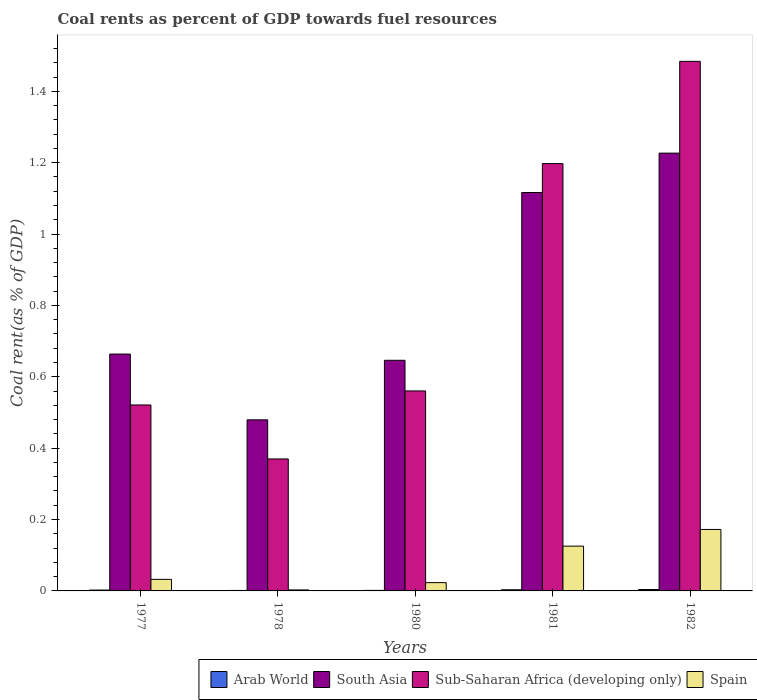How many groups of bars are there?
Your response must be concise. 5. Are the number of bars per tick equal to the number of legend labels?
Provide a short and direct response. Yes. Are the number of bars on each tick of the X-axis equal?
Offer a very short reply. Yes. How many bars are there on the 5th tick from the right?
Provide a succinct answer. 4. In how many cases, is the number of bars for a given year not equal to the number of legend labels?
Offer a terse response. 0. What is the coal rent in South Asia in 1977?
Provide a succinct answer. 0.66. Across all years, what is the maximum coal rent in Sub-Saharan Africa (developing only)?
Provide a short and direct response. 1.48. Across all years, what is the minimum coal rent in Arab World?
Provide a succinct answer. 0. In which year was the coal rent in Spain maximum?
Provide a short and direct response. 1982. In which year was the coal rent in Arab World minimum?
Ensure brevity in your answer.  1978. What is the total coal rent in South Asia in the graph?
Your response must be concise. 4.13. What is the difference between the coal rent in Arab World in 1978 and that in 1981?
Your response must be concise. -0. What is the difference between the coal rent in Arab World in 1981 and the coal rent in South Asia in 1980?
Offer a terse response. -0.64. What is the average coal rent in Arab World per year?
Provide a short and direct response. 0. In the year 1981, what is the difference between the coal rent in Arab World and coal rent in Spain?
Your answer should be very brief. -0.12. In how many years, is the coal rent in Spain greater than 1.08 %?
Ensure brevity in your answer.  0. What is the ratio of the coal rent in Spain in 1980 to that in 1982?
Make the answer very short. 0.13. Is the coal rent in Arab World in 1980 less than that in 1982?
Your response must be concise. Yes. Is the difference between the coal rent in Arab World in 1980 and 1981 greater than the difference between the coal rent in Spain in 1980 and 1981?
Ensure brevity in your answer.  Yes. What is the difference between the highest and the second highest coal rent in Sub-Saharan Africa (developing only)?
Make the answer very short. 0.29. What is the difference between the highest and the lowest coal rent in Arab World?
Offer a terse response. 0. Is it the case that in every year, the sum of the coal rent in Spain and coal rent in Arab World is greater than the sum of coal rent in South Asia and coal rent in Sub-Saharan Africa (developing only)?
Give a very brief answer. No. What does the 1st bar from the left in 1977 represents?
Ensure brevity in your answer.  Arab World. What does the 4th bar from the right in 1978 represents?
Your answer should be very brief. Arab World. How many bars are there?
Offer a terse response. 20. Are all the bars in the graph horizontal?
Provide a succinct answer. No. What is the difference between two consecutive major ticks on the Y-axis?
Your answer should be very brief. 0.2. Does the graph contain any zero values?
Your answer should be compact. No. Does the graph contain grids?
Give a very brief answer. No. How many legend labels are there?
Your answer should be compact. 4. How are the legend labels stacked?
Keep it short and to the point. Horizontal. What is the title of the graph?
Your answer should be very brief. Coal rents as percent of GDP towards fuel resources. What is the label or title of the X-axis?
Give a very brief answer. Years. What is the label or title of the Y-axis?
Offer a very short reply. Coal rent(as % of GDP). What is the Coal rent(as % of GDP) in Arab World in 1977?
Offer a terse response. 0. What is the Coal rent(as % of GDP) of South Asia in 1977?
Make the answer very short. 0.66. What is the Coal rent(as % of GDP) of Sub-Saharan Africa (developing only) in 1977?
Offer a terse response. 0.52. What is the Coal rent(as % of GDP) in Spain in 1977?
Give a very brief answer. 0.03. What is the Coal rent(as % of GDP) of Arab World in 1978?
Make the answer very short. 0. What is the Coal rent(as % of GDP) in South Asia in 1978?
Your response must be concise. 0.48. What is the Coal rent(as % of GDP) in Sub-Saharan Africa (developing only) in 1978?
Keep it short and to the point. 0.37. What is the Coal rent(as % of GDP) in Spain in 1978?
Ensure brevity in your answer.  0. What is the Coal rent(as % of GDP) of Arab World in 1980?
Your answer should be very brief. 0. What is the Coal rent(as % of GDP) of South Asia in 1980?
Provide a succinct answer. 0.65. What is the Coal rent(as % of GDP) of Sub-Saharan Africa (developing only) in 1980?
Your answer should be very brief. 0.56. What is the Coal rent(as % of GDP) in Spain in 1980?
Your answer should be very brief. 0.02. What is the Coal rent(as % of GDP) of Arab World in 1981?
Offer a very short reply. 0. What is the Coal rent(as % of GDP) in South Asia in 1981?
Ensure brevity in your answer.  1.12. What is the Coal rent(as % of GDP) in Sub-Saharan Africa (developing only) in 1981?
Your response must be concise. 1.2. What is the Coal rent(as % of GDP) of Spain in 1981?
Your response must be concise. 0.13. What is the Coal rent(as % of GDP) in Arab World in 1982?
Offer a very short reply. 0. What is the Coal rent(as % of GDP) of South Asia in 1982?
Your answer should be very brief. 1.23. What is the Coal rent(as % of GDP) of Sub-Saharan Africa (developing only) in 1982?
Ensure brevity in your answer.  1.48. What is the Coal rent(as % of GDP) in Spain in 1982?
Offer a terse response. 0.17. Across all years, what is the maximum Coal rent(as % of GDP) of Arab World?
Your answer should be compact. 0. Across all years, what is the maximum Coal rent(as % of GDP) of South Asia?
Your answer should be very brief. 1.23. Across all years, what is the maximum Coal rent(as % of GDP) in Sub-Saharan Africa (developing only)?
Make the answer very short. 1.48. Across all years, what is the maximum Coal rent(as % of GDP) of Spain?
Make the answer very short. 0.17. Across all years, what is the minimum Coal rent(as % of GDP) of Arab World?
Give a very brief answer. 0. Across all years, what is the minimum Coal rent(as % of GDP) in South Asia?
Provide a succinct answer. 0.48. Across all years, what is the minimum Coal rent(as % of GDP) of Sub-Saharan Africa (developing only)?
Provide a short and direct response. 0.37. Across all years, what is the minimum Coal rent(as % of GDP) in Spain?
Provide a short and direct response. 0. What is the total Coal rent(as % of GDP) in Arab World in the graph?
Offer a terse response. 0.01. What is the total Coal rent(as % of GDP) in South Asia in the graph?
Give a very brief answer. 4.13. What is the total Coal rent(as % of GDP) in Sub-Saharan Africa (developing only) in the graph?
Your answer should be very brief. 4.13. What is the total Coal rent(as % of GDP) in Spain in the graph?
Your response must be concise. 0.36. What is the difference between the Coal rent(as % of GDP) in Arab World in 1977 and that in 1978?
Ensure brevity in your answer.  0. What is the difference between the Coal rent(as % of GDP) in South Asia in 1977 and that in 1978?
Keep it short and to the point. 0.18. What is the difference between the Coal rent(as % of GDP) of Sub-Saharan Africa (developing only) in 1977 and that in 1978?
Offer a terse response. 0.15. What is the difference between the Coal rent(as % of GDP) of Spain in 1977 and that in 1978?
Your answer should be very brief. 0.03. What is the difference between the Coal rent(as % of GDP) in Arab World in 1977 and that in 1980?
Offer a very short reply. 0. What is the difference between the Coal rent(as % of GDP) of South Asia in 1977 and that in 1980?
Your answer should be very brief. 0.02. What is the difference between the Coal rent(as % of GDP) of Sub-Saharan Africa (developing only) in 1977 and that in 1980?
Keep it short and to the point. -0.04. What is the difference between the Coal rent(as % of GDP) in Spain in 1977 and that in 1980?
Your answer should be compact. 0.01. What is the difference between the Coal rent(as % of GDP) in Arab World in 1977 and that in 1981?
Keep it short and to the point. -0. What is the difference between the Coal rent(as % of GDP) of South Asia in 1977 and that in 1981?
Provide a short and direct response. -0.45. What is the difference between the Coal rent(as % of GDP) in Sub-Saharan Africa (developing only) in 1977 and that in 1981?
Provide a short and direct response. -0.68. What is the difference between the Coal rent(as % of GDP) in Spain in 1977 and that in 1981?
Your answer should be very brief. -0.09. What is the difference between the Coal rent(as % of GDP) of Arab World in 1977 and that in 1982?
Give a very brief answer. -0. What is the difference between the Coal rent(as % of GDP) in South Asia in 1977 and that in 1982?
Offer a terse response. -0.56. What is the difference between the Coal rent(as % of GDP) in Sub-Saharan Africa (developing only) in 1977 and that in 1982?
Your answer should be very brief. -0.96. What is the difference between the Coal rent(as % of GDP) in Spain in 1977 and that in 1982?
Your answer should be compact. -0.14. What is the difference between the Coal rent(as % of GDP) of Arab World in 1978 and that in 1980?
Provide a short and direct response. -0. What is the difference between the Coal rent(as % of GDP) in South Asia in 1978 and that in 1980?
Give a very brief answer. -0.17. What is the difference between the Coal rent(as % of GDP) in Sub-Saharan Africa (developing only) in 1978 and that in 1980?
Keep it short and to the point. -0.19. What is the difference between the Coal rent(as % of GDP) in Spain in 1978 and that in 1980?
Ensure brevity in your answer.  -0.02. What is the difference between the Coal rent(as % of GDP) in Arab World in 1978 and that in 1981?
Offer a very short reply. -0. What is the difference between the Coal rent(as % of GDP) in South Asia in 1978 and that in 1981?
Provide a short and direct response. -0.64. What is the difference between the Coal rent(as % of GDP) in Sub-Saharan Africa (developing only) in 1978 and that in 1981?
Provide a succinct answer. -0.83. What is the difference between the Coal rent(as % of GDP) in Spain in 1978 and that in 1981?
Offer a terse response. -0.12. What is the difference between the Coal rent(as % of GDP) of Arab World in 1978 and that in 1982?
Offer a very short reply. -0. What is the difference between the Coal rent(as % of GDP) in South Asia in 1978 and that in 1982?
Ensure brevity in your answer.  -0.75. What is the difference between the Coal rent(as % of GDP) of Sub-Saharan Africa (developing only) in 1978 and that in 1982?
Your answer should be very brief. -1.11. What is the difference between the Coal rent(as % of GDP) of Spain in 1978 and that in 1982?
Your answer should be compact. -0.17. What is the difference between the Coal rent(as % of GDP) of Arab World in 1980 and that in 1981?
Make the answer very short. -0. What is the difference between the Coal rent(as % of GDP) of South Asia in 1980 and that in 1981?
Offer a very short reply. -0.47. What is the difference between the Coal rent(as % of GDP) of Sub-Saharan Africa (developing only) in 1980 and that in 1981?
Offer a terse response. -0.64. What is the difference between the Coal rent(as % of GDP) of Spain in 1980 and that in 1981?
Provide a succinct answer. -0.1. What is the difference between the Coal rent(as % of GDP) in Arab World in 1980 and that in 1982?
Your response must be concise. -0. What is the difference between the Coal rent(as % of GDP) of South Asia in 1980 and that in 1982?
Make the answer very short. -0.58. What is the difference between the Coal rent(as % of GDP) of Sub-Saharan Africa (developing only) in 1980 and that in 1982?
Offer a terse response. -0.92. What is the difference between the Coal rent(as % of GDP) of Spain in 1980 and that in 1982?
Make the answer very short. -0.15. What is the difference between the Coal rent(as % of GDP) in Arab World in 1981 and that in 1982?
Offer a terse response. -0. What is the difference between the Coal rent(as % of GDP) of South Asia in 1981 and that in 1982?
Your response must be concise. -0.11. What is the difference between the Coal rent(as % of GDP) in Sub-Saharan Africa (developing only) in 1981 and that in 1982?
Offer a terse response. -0.29. What is the difference between the Coal rent(as % of GDP) in Spain in 1981 and that in 1982?
Make the answer very short. -0.05. What is the difference between the Coal rent(as % of GDP) in Arab World in 1977 and the Coal rent(as % of GDP) in South Asia in 1978?
Your answer should be compact. -0.48. What is the difference between the Coal rent(as % of GDP) of Arab World in 1977 and the Coal rent(as % of GDP) of Sub-Saharan Africa (developing only) in 1978?
Make the answer very short. -0.37. What is the difference between the Coal rent(as % of GDP) in Arab World in 1977 and the Coal rent(as % of GDP) in Spain in 1978?
Provide a short and direct response. -0. What is the difference between the Coal rent(as % of GDP) of South Asia in 1977 and the Coal rent(as % of GDP) of Sub-Saharan Africa (developing only) in 1978?
Make the answer very short. 0.29. What is the difference between the Coal rent(as % of GDP) in South Asia in 1977 and the Coal rent(as % of GDP) in Spain in 1978?
Your response must be concise. 0.66. What is the difference between the Coal rent(as % of GDP) of Sub-Saharan Africa (developing only) in 1977 and the Coal rent(as % of GDP) of Spain in 1978?
Provide a short and direct response. 0.52. What is the difference between the Coal rent(as % of GDP) in Arab World in 1977 and the Coal rent(as % of GDP) in South Asia in 1980?
Provide a short and direct response. -0.64. What is the difference between the Coal rent(as % of GDP) of Arab World in 1977 and the Coal rent(as % of GDP) of Sub-Saharan Africa (developing only) in 1980?
Ensure brevity in your answer.  -0.56. What is the difference between the Coal rent(as % of GDP) of Arab World in 1977 and the Coal rent(as % of GDP) of Spain in 1980?
Keep it short and to the point. -0.02. What is the difference between the Coal rent(as % of GDP) in South Asia in 1977 and the Coal rent(as % of GDP) in Sub-Saharan Africa (developing only) in 1980?
Your response must be concise. 0.1. What is the difference between the Coal rent(as % of GDP) of South Asia in 1977 and the Coal rent(as % of GDP) of Spain in 1980?
Provide a short and direct response. 0.64. What is the difference between the Coal rent(as % of GDP) of Sub-Saharan Africa (developing only) in 1977 and the Coal rent(as % of GDP) of Spain in 1980?
Make the answer very short. 0.5. What is the difference between the Coal rent(as % of GDP) in Arab World in 1977 and the Coal rent(as % of GDP) in South Asia in 1981?
Give a very brief answer. -1.11. What is the difference between the Coal rent(as % of GDP) in Arab World in 1977 and the Coal rent(as % of GDP) in Sub-Saharan Africa (developing only) in 1981?
Ensure brevity in your answer.  -1.2. What is the difference between the Coal rent(as % of GDP) in Arab World in 1977 and the Coal rent(as % of GDP) in Spain in 1981?
Your answer should be compact. -0.12. What is the difference between the Coal rent(as % of GDP) of South Asia in 1977 and the Coal rent(as % of GDP) of Sub-Saharan Africa (developing only) in 1981?
Your answer should be very brief. -0.53. What is the difference between the Coal rent(as % of GDP) of South Asia in 1977 and the Coal rent(as % of GDP) of Spain in 1981?
Offer a very short reply. 0.54. What is the difference between the Coal rent(as % of GDP) of Sub-Saharan Africa (developing only) in 1977 and the Coal rent(as % of GDP) of Spain in 1981?
Offer a terse response. 0.4. What is the difference between the Coal rent(as % of GDP) in Arab World in 1977 and the Coal rent(as % of GDP) in South Asia in 1982?
Provide a short and direct response. -1.22. What is the difference between the Coal rent(as % of GDP) in Arab World in 1977 and the Coal rent(as % of GDP) in Sub-Saharan Africa (developing only) in 1982?
Ensure brevity in your answer.  -1.48. What is the difference between the Coal rent(as % of GDP) of Arab World in 1977 and the Coal rent(as % of GDP) of Spain in 1982?
Offer a very short reply. -0.17. What is the difference between the Coal rent(as % of GDP) of South Asia in 1977 and the Coal rent(as % of GDP) of Sub-Saharan Africa (developing only) in 1982?
Offer a terse response. -0.82. What is the difference between the Coal rent(as % of GDP) in South Asia in 1977 and the Coal rent(as % of GDP) in Spain in 1982?
Keep it short and to the point. 0.49. What is the difference between the Coal rent(as % of GDP) of Sub-Saharan Africa (developing only) in 1977 and the Coal rent(as % of GDP) of Spain in 1982?
Provide a succinct answer. 0.35. What is the difference between the Coal rent(as % of GDP) of Arab World in 1978 and the Coal rent(as % of GDP) of South Asia in 1980?
Your response must be concise. -0.64. What is the difference between the Coal rent(as % of GDP) in Arab World in 1978 and the Coal rent(as % of GDP) in Sub-Saharan Africa (developing only) in 1980?
Provide a succinct answer. -0.56. What is the difference between the Coal rent(as % of GDP) of Arab World in 1978 and the Coal rent(as % of GDP) of Spain in 1980?
Your answer should be very brief. -0.02. What is the difference between the Coal rent(as % of GDP) of South Asia in 1978 and the Coal rent(as % of GDP) of Sub-Saharan Africa (developing only) in 1980?
Give a very brief answer. -0.08. What is the difference between the Coal rent(as % of GDP) in South Asia in 1978 and the Coal rent(as % of GDP) in Spain in 1980?
Make the answer very short. 0.46. What is the difference between the Coal rent(as % of GDP) in Sub-Saharan Africa (developing only) in 1978 and the Coal rent(as % of GDP) in Spain in 1980?
Provide a succinct answer. 0.35. What is the difference between the Coal rent(as % of GDP) of Arab World in 1978 and the Coal rent(as % of GDP) of South Asia in 1981?
Ensure brevity in your answer.  -1.11. What is the difference between the Coal rent(as % of GDP) in Arab World in 1978 and the Coal rent(as % of GDP) in Sub-Saharan Africa (developing only) in 1981?
Your response must be concise. -1.2. What is the difference between the Coal rent(as % of GDP) in Arab World in 1978 and the Coal rent(as % of GDP) in Spain in 1981?
Provide a short and direct response. -0.12. What is the difference between the Coal rent(as % of GDP) in South Asia in 1978 and the Coal rent(as % of GDP) in Sub-Saharan Africa (developing only) in 1981?
Your answer should be very brief. -0.72. What is the difference between the Coal rent(as % of GDP) in South Asia in 1978 and the Coal rent(as % of GDP) in Spain in 1981?
Your answer should be compact. 0.35. What is the difference between the Coal rent(as % of GDP) in Sub-Saharan Africa (developing only) in 1978 and the Coal rent(as % of GDP) in Spain in 1981?
Your answer should be compact. 0.24. What is the difference between the Coal rent(as % of GDP) of Arab World in 1978 and the Coal rent(as % of GDP) of South Asia in 1982?
Keep it short and to the point. -1.23. What is the difference between the Coal rent(as % of GDP) of Arab World in 1978 and the Coal rent(as % of GDP) of Sub-Saharan Africa (developing only) in 1982?
Provide a short and direct response. -1.48. What is the difference between the Coal rent(as % of GDP) of Arab World in 1978 and the Coal rent(as % of GDP) of Spain in 1982?
Offer a very short reply. -0.17. What is the difference between the Coal rent(as % of GDP) in South Asia in 1978 and the Coal rent(as % of GDP) in Sub-Saharan Africa (developing only) in 1982?
Provide a short and direct response. -1. What is the difference between the Coal rent(as % of GDP) in South Asia in 1978 and the Coal rent(as % of GDP) in Spain in 1982?
Give a very brief answer. 0.31. What is the difference between the Coal rent(as % of GDP) in Sub-Saharan Africa (developing only) in 1978 and the Coal rent(as % of GDP) in Spain in 1982?
Your answer should be compact. 0.2. What is the difference between the Coal rent(as % of GDP) of Arab World in 1980 and the Coal rent(as % of GDP) of South Asia in 1981?
Your response must be concise. -1.11. What is the difference between the Coal rent(as % of GDP) in Arab World in 1980 and the Coal rent(as % of GDP) in Sub-Saharan Africa (developing only) in 1981?
Your answer should be compact. -1.2. What is the difference between the Coal rent(as % of GDP) of Arab World in 1980 and the Coal rent(as % of GDP) of Spain in 1981?
Offer a very short reply. -0.12. What is the difference between the Coal rent(as % of GDP) in South Asia in 1980 and the Coal rent(as % of GDP) in Sub-Saharan Africa (developing only) in 1981?
Provide a short and direct response. -0.55. What is the difference between the Coal rent(as % of GDP) in South Asia in 1980 and the Coal rent(as % of GDP) in Spain in 1981?
Offer a very short reply. 0.52. What is the difference between the Coal rent(as % of GDP) of Sub-Saharan Africa (developing only) in 1980 and the Coal rent(as % of GDP) of Spain in 1981?
Your answer should be very brief. 0.43. What is the difference between the Coal rent(as % of GDP) in Arab World in 1980 and the Coal rent(as % of GDP) in South Asia in 1982?
Make the answer very short. -1.23. What is the difference between the Coal rent(as % of GDP) in Arab World in 1980 and the Coal rent(as % of GDP) in Sub-Saharan Africa (developing only) in 1982?
Make the answer very short. -1.48. What is the difference between the Coal rent(as % of GDP) in Arab World in 1980 and the Coal rent(as % of GDP) in Spain in 1982?
Your response must be concise. -0.17. What is the difference between the Coal rent(as % of GDP) of South Asia in 1980 and the Coal rent(as % of GDP) of Sub-Saharan Africa (developing only) in 1982?
Keep it short and to the point. -0.84. What is the difference between the Coal rent(as % of GDP) in South Asia in 1980 and the Coal rent(as % of GDP) in Spain in 1982?
Keep it short and to the point. 0.47. What is the difference between the Coal rent(as % of GDP) of Sub-Saharan Africa (developing only) in 1980 and the Coal rent(as % of GDP) of Spain in 1982?
Keep it short and to the point. 0.39. What is the difference between the Coal rent(as % of GDP) in Arab World in 1981 and the Coal rent(as % of GDP) in South Asia in 1982?
Make the answer very short. -1.22. What is the difference between the Coal rent(as % of GDP) in Arab World in 1981 and the Coal rent(as % of GDP) in Sub-Saharan Africa (developing only) in 1982?
Make the answer very short. -1.48. What is the difference between the Coal rent(as % of GDP) in Arab World in 1981 and the Coal rent(as % of GDP) in Spain in 1982?
Give a very brief answer. -0.17. What is the difference between the Coal rent(as % of GDP) in South Asia in 1981 and the Coal rent(as % of GDP) in Sub-Saharan Africa (developing only) in 1982?
Keep it short and to the point. -0.37. What is the difference between the Coal rent(as % of GDP) of South Asia in 1981 and the Coal rent(as % of GDP) of Spain in 1982?
Offer a very short reply. 0.94. What is the difference between the Coal rent(as % of GDP) of Sub-Saharan Africa (developing only) in 1981 and the Coal rent(as % of GDP) of Spain in 1982?
Give a very brief answer. 1.03. What is the average Coal rent(as % of GDP) of Arab World per year?
Give a very brief answer. 0. What is the average Coal rent(as % of GDP) of South Asia per year?
Your answer should be very brief. 0.83. What is the average Coal rent(as % of GDP) of Sub-Saharan Africa (developing only) per year?
Provide a succinct answer. 0.83. What is the average Coal rent(as % of GDP) in Spain per year?
Offer a very short reply. 0.07. In the year 1977, what is the difference between the Coal rent(as % of GDP) of Arab World and Coal rent(as % of GDP) of South Asia?
Provide a short and direct response. -0.66. In the year 1977, what is the difference between the Coal rent(as % of GDP) of Arab World and Coal rent(as % of GDP) of Sub-Saharan Africa (developing only)?
Give a very brief answer. -0.52. In the year 1977, what is the difference between the Coal rent(as % of GDP) of Arab World and Coal rent(as % of GDP) of Spain?
Offer a very short reply. -0.03. In the year 1977, what is the difference between the Coal rent(as % of GDP) in South Asia and Coal rent(as % of GDP) in Sub-Saharan Africa (developing only)?
Your answer should be compact. 0.14. In the year 1977, what is the difference between the Coal rent(as % of GDP) in South Asia and Coal rent(as % of GDP) in Spain?
Offer a terse response. 0.63. In the year 1977, what is the difference between the Coal rent(as % of GDP) in Sub-Saharan Africa (developing only) and Coal rent(as % of GDP) in Spain?
Provide a short and direct response. 0.49. In the year 1978, what is the difference between the Coal rent(as % of GDP) of Arab World and Coal rent(as % of GDP) of South Asia?
Provide a short and direct response. -0.48. In the year 1978, what is the difference between the Coal rent(as % of GDP) in Arab World and Coal rent(as % of GDP) in Sub-Saharan Africa (developing only)?
Give a very brief answer. -0.37. In the year 1978, what is the difference between the Coal rent(as % of GDP) in Arab World and Coal rent(as % of GDP) in Spain?
Your response must be concise. -0. In the year 1978, what is the difference between the Coal rent(as % of GDP) in South Asia and Coal rent(as % of GDP) in Sub-Saharan Africa (developing only)?
Your answer should be very brief. 0.11. In the year 1978, what is the difference between the Coal rent(as % of GDP) of South Asia and Coal rent(as % of GDP) of Spain?
Your answer should be very brief. 0.48. In the year 1978, what is the difference between the Coal rent(as % of GDP) in Sub-Saharan Africa (developing only) and Coal rent(as % of GDP) in Spain?
Keep it short and to the point. 0.37. In the year 1980, what is the difference between the Coal rent(as % of GDP) of Arab World and Coal rent(as % of GDP) of South Asia?
Your answer should be very brief. -0.64. In the year 1980, what is the difference between the Coal rent(as % of GDP) in Arab World and Coal rent(as % of GDP) in Sub-Saharan Africa (developing only)?
Your response must be concise. -0.56. In the year 1980, what is the difference between the Coal rent(as % of GDP) in Arab World and Coal rent(as % of GDP) in Spain?
Give a very brief answer. -0.02. In the year 1980, what is the difference between the Coal rent(as % of GDP) in South Asia and Coal rent(as % of GDP) in Sub-Saharan Africa (developing only)?
Your answer should be compact. 0.09. In the year 1980, what is the difference between the Coal rent(as % of GDP) in South Asia and Coal rent(as % of GDP) in Spain?
Offer a very short reply. 0.62. In the year 1980, what is the difference between the Coal rent(as % of GDP) in Sub-Saharan Africa (developing only) and Coal rent(as % of GDP) in Spain?
Provide a short and direct response. 0.54. In the year 1981, what is the difference between the Coal rent(as % of GDP) in Arab World and Coal rent(as % of GDP) in South Asia?
Ensure brevity in your answer.  -1.11. In the year 1981, what is the difference between the Coal rent(as % of GDP) of Arab World and Coal rent(as % of GDP) of Sub-Saharan Africa (developing only)?
Give a very brief answer. -1.19. In the year 1981, what is the difference between the Coal rent(as % of GDP) in Arab World and Coal rent(as % of GDP) in Spain?
Give a very brief answer. -0.12. In the year 1981, what is the difference between the Coal rent(as % of GDP) in South Asia and Coal rent(as % of GDP) in Sub-Saharan Africa (developing only)?
Provide a succinct answer. -0.08. In the year 1981, what is the difference between the Coal rent(as % of GDP) in Sub-Saharan Africa (developing only) and Coal rent(as % of GDP) in Spain?
Offer a very short reply. 1.07. In the year 1982, what is the difference between the Coal rent(as % of GDP) in Arab World and Coal rent(as % of GDP) in South Asia?
Give a very brief answer. -1.22. In the year 1982, what is the difference between the Coal rent(as % of GDP) of Arab World and Coal rent(as % of GDP) of Sub-Saharan Africa (developing only)?
Ensure brevity in your answer.  -1.48. In the year 1982, what is the difference between the Coal rent(as % of GDP) in Arab World and Coal rent(as % of GDP) in Spain?
Give a very brief answer. -0.17. In the year 1982, what is the difference between the Coal rent(as % of GDP) of South Asia and Coal rent(as % of GDP) of Sub-Saharan Africa (developing only)?
Give a very brief answer. -0.26. In the year 1982, what is the difference between the Coal rent(as % of GDP) of South Asia and Coal rent(as % of GDP) of Spain?
Ensure brevity in your answer.  1.05. In the year 1982, what is the difference between the Coal rent(as % of GDP) in Sub-Saharan Africa (developing only) and Coal rent(as % of GDP) in Spain?
Provide a short and direct response. 1.31. What is the ratio of the Coal rent(as % of GDP) of Arab World in 1977 to that in 1978?
Provide a short and direct response. 1.83. What is the ratio of the Coal rent(as % of GDP) in South Asia in 1977 to that in 1978?
Your answer should be very brief. 1.38. What is the ratio of the Coal rent(as % of GDP) of Sub-Saharan Africa (developing only) in 1977 to that in 1978?
Your answer should be very brief. 1.41. What is the ratio of the Coal rent(as % of GDP) of Spain in 1977 to that in 1978?
Offer a terse response. 11.53. What is the ratio of the Coal rent(as % of GDP) in Arab World in 1977 to that in 1980?
Keep it short and to the point. 1.62. What is the ratio of the Coal rent(as % of GDP) of South Asia in 1977 to that in 1980?
Ensure brevity in your answer.  1.03. What is the ratio of the Coal rent(as % of GDP) in Sub-Saharan Africa (developing only) in 1977 to that in 1980?
Provide a succinct answer. 0.93. What is the ratio of the Coal rent(as % of GDP) in Spain in 1977 to that in 1980?
Make the answer very short. 1.39. What is the ratio of the Coal rent(as % of GDP) in Arab World in 1977 to that in 1981?
Make the answer very short. 0.76. What is the ratio of the Coal rent(as % of GDP) in South Asia in 1977 to that in 1981?
Ensure brevity in your answer.  0.59. What is the ratio of the Coal rent(as % of GDP) in Sub-Saharan Africa (developing only) in 1977 to that in 1981?
Offer a very short reply. 0.44. What is the ratio of the Coal rent(as % of GDP) of Spain in 1977 to that in 1981?
Your answer should be compact. 0.26. What is the ratio of the Coal rent(as % of GDP) of Arab World in 1977 to that in 1982?
Offer a terse response. 0.62. What is the ratio of the Coal rent(as % of GDP) in South Asia in 1977 to that in 1982?
Your answer should be compact. 0.54. What is the ratio of the Coal rent(as % of GDP) in Sub-Saharan Africa (developing only) in 1977 to that in 1982?
Offer a terse response. 0.35. What is the ratio of the Coal rent(as % of GDP) of Spain in 1977 to that in 1982?
Your answer should be compact. 0.19. What is the ratio of the Coal rent(as % of GDP) of Arab World in 1978 to that in 1980?
Provide a short and direct response. 0.88. What is the ratio of the Coal rent(as % of GDP) of South Asia in 1978 to that in 1980?
Make the answer very short. 0.74. What is the ratio of the Coal rent(as % of GDP) of Sub-Saharan Africa (developing only) in 1978 to that in 1980?
Provide a short and direct response. 0.66. What is the ratio of the Coal rent(as % of GDP) of Spain in 1978 to that in 1980?
Provide a succinct answer. 0.12. What is the ratio of the Coal rent(as % of GDP) of Arab World in 1978 to that in 1981?
Keep it short and to the point. 0.41. What is the ratio of the Coal rent(as % of GDP) in South Asia in 1978 to that in 1981?
Offer a very short reply. 0.43. What is the ratio of the Coal rent(as % of GDP) in Sub-Saharan Africa (developing only) in 1978 to that in 1981?
Ensure brevity in your answer.  0.31. What is the ratio of the Coal rent(as % of GDP) of Spain in 1978 to that in 1981?
Offer a terse response. 0.02. What is the ratio of the Coal rent(as % of GDP) in Arab World in 1978 to that in 1982?
Your answer should be very brief. 0.34. What is the ratio of the Coal rent(as % of GDP) in South Asia in 1978 to that in 1982?
Provide a short and direct response. 0.39. What is the ratio of the Coal rent(as % of GDP) of Sub-Saharan Africa (developing only) in 1978 to that in 1982?
Offer a very short reply. 0.25. What is the ratio of the Coal rent(as % of GDP) of Spain in 1978 to that in 1982?
Provide a short and direct response. 0.02. What is the ratio of the Coal rent(as % of GDP) in Arab World in 1980 to that in 1981?
Give a very brief answer. 0.47. What is the ratio of the Coal rent(as % of GDP) of South Asia in 1980 to that in 1981?
Offer a very short reply. 0.58. What is the ratio of the Coal rent(as % of GDP) in Sub-Saharan Africa (developing only) in 1980 to that in 1981?
Give a very brief answer. 0.47. What is the ratio of the Coal rent(as % of GDP) of Spain in 1980 to that in 1981?
Your response must be concise. 0.19. What is the ratio of the Coal rent(as % of GDP) in Arab World in 1980 to that in 1982?
Provide a succinct answer. 0.39. What is the ratio of the Coal rent(as % of GDP) in South Asia in 1980 to that in 1982?
Give a very brief answer. 0.53. What is the ratio of the Coal rent(as % of GDP) in Sub-Saharan Africa (developing only) in 1980 to that in 1982?
Your response must be concise. 0.38. What is the ratio of the Coal rent(as % of GDP) of Spain in 1980 to that in 1982?
Provide a succinct answer. 0.14. What is the ratio of the Coal rent(as % of GDP) in Arab World in 1981 to that in 1982?
Ensure brevity in your answer.  0.82. What is the ratio of the Coal rent(as % of GDP) of South Asia in 1981 to that in 1982?
Give a very brief answer. 0.91. What is the ratio of the Coal rent(as % of GDP) in Sub-Saharan Africa (developing only) in 1981 to that in 1982?
Offer a very short reply. 0.81. What is the ratio of the Coal rent(as % of GDP) in Spain in 1981 to that in 1982?
Your response must be concise. 0.73. What is the difference between the highest and the second highest Coal rent(as % of GDP) in Arab World?
Your answer should be very brief. 0. What is the difference between the highest and the second highest Coal rent(as % of GDP) in South Asia?
Your answer should be compact. 0.11. What is the difference between the highest and the second highest Coal rent(as % of GDP) in Sub-Saharan Africa (developing only)?
Ensure brevity in your answer.  0.29. What is the difference between the highest and the second highest Coal rent(as % of GDP) of Spain?
Keep it short and to the point. 0.05. What is the difference between the highest and the lowest Coal rent(as % of GDP) in Arab World?
Provide a short and direct response. 0. What is the difference between the highest and the lowest Coal rent(as % of GDP) in South Asia?
Make the answer very short. 0.75. What is the difference between the highest and the lowest Coal rent(as % of GDP) in Sub-Saharan Africa (developing only)?
Your answer should be compact. 1.11. What is the difference between the highest and the lowest Coal rent(as % of GDP) in Spain?
Give a very brief answer. 0.17. 